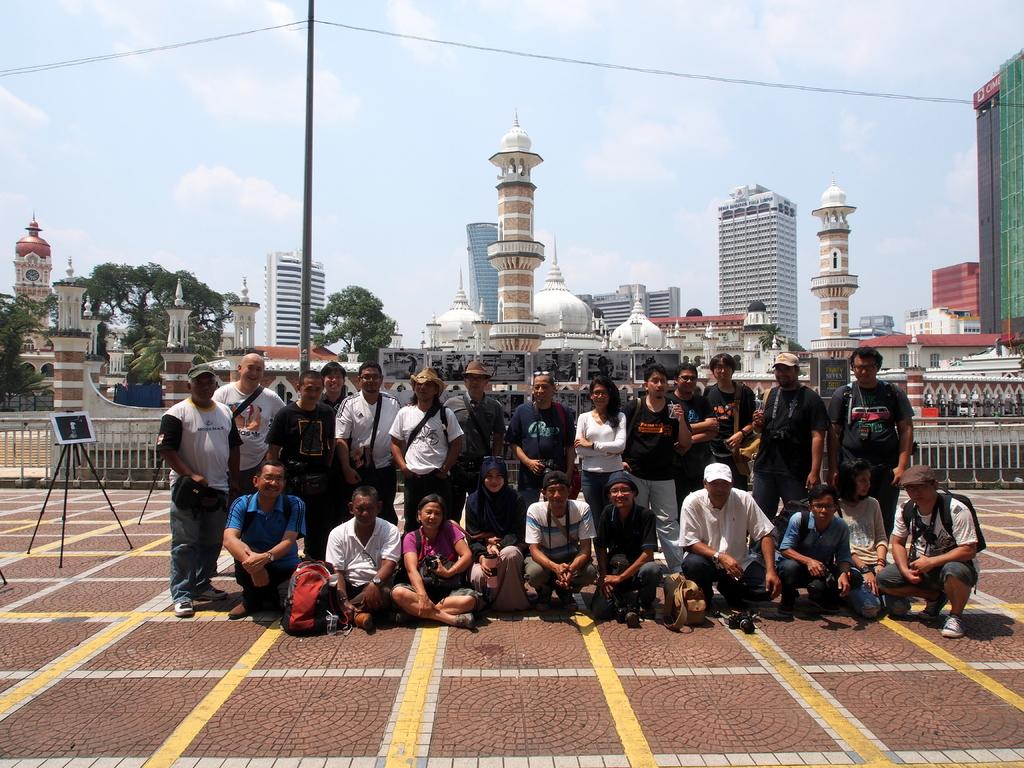How many people are in the group in the image? There is a group of people in the image, but the exact number is not specified. What are some of the people in the group doing? Some people in the group are sitting, while others are standing. What might some of the people in the group be carrying? Some people in the group are carrying bags. What can be seen in the background of the image? There are buildings and trees in the background of the image. What day of the week is depicted in the image? The day of the week is not mentioned or depicted in the image. What type of treatment is being administered to the people in the image? There is no indication of any treatment being administered to the people in the image. 